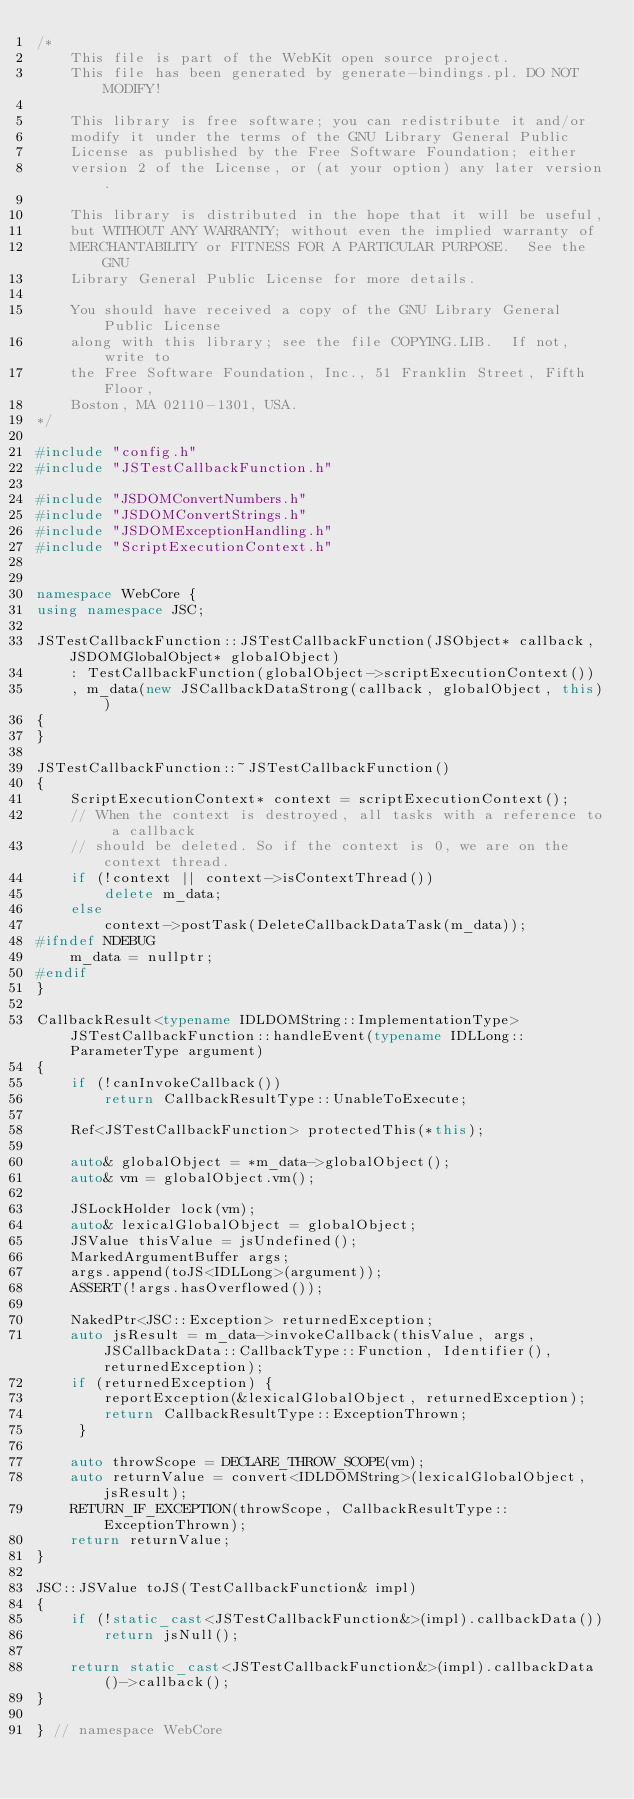Convert code to text. <code><loc_0><loc_0><loc_500><loc_500><_C++_>/*
    This file is part of the WebKit open source project.
    This file has been generated by generate-bindings.pl. DO NOT MODIFY!

    This library is free software; you can redistribute it and/or
    modify it under the terms of the GNU Library General Public
    License as published by the Free Software Foundation; either
    version 2 of the License, or (at your option) any later version.

    This library is distributed in the hope that it will be useful,
    but WITHOUT ANY WARRANTY; without even the implied warranty of
    MERCHANTABILITY or FITNESS FOR A PARTICULAR PURPOSE.  See the GNU
    Library General Public License for more details.

    You should have received a copy of the GNU Library General Public License
    along with this library; see the file COPYING.LIB.  If not, write to
    the Free Software Foundation, Inc., 51 Franklin Street, Fifth Floor,
    Boston, MA 02110-1301, USA.
*/

#include "config.h"
#include "JSTestCallbackFunction.h"

#include "JSDOMConvertNumbers.h"
#include "JSDOMConvertStrings.h"
#include "JSDOMExceptionHandling.h"
#include "ScriptExecutionContext.h"


namespace WebCore {
using namespace JSC;

JSTestCallbackFunction::JSTestCallbackFunction(JSObject* callback, JSDOMGlobalObject* globalObject)
    : TestCallbackFunction(globalObject->scriptExecutionContext())
    , m_data(new JSCallbackDataStrong(callback, globalObject, this))
{
}

JSTestCallbackFunction::~JSTestCallbackFunction()
{
    ScriptExecutionContext* context = scriptExecutionContext();
    // When the context is destroyed, all tasks with a reference to a callback
    // should be deleted. So if the context is 0, we are on the context thread.
    if (!context || context->isContextThread())
        delete m_data;
    else
        context->postTask(DeleteCallbackDataTask(m_data));
#ifndef NDEBUG
    m_data = nullptr;
#endif
}

CallbackResult<typename IDLDOMString::ImplementationType> JSTestCallbackFunction::handleEvent(typename IDLLong::ParameterType argument)
{
    if (!canInvokeCallback())
        return CallbackResultType::UnableToExecute;

    Ref<JSTestCallbackFunction> protectedThis(*this);

    auto& globalObject = *m_data->globalObject();
    auto& vm = globalObject.vm();

    JSLockHolder lock(vm);
    auto& lexicalGlobalObject = globalObject;
    JSValue thisValue = jsUndefined();
    MarkedArgumentBuffer args;
    args.append(toJS<IDLLong>(argument));
    ASSERT(!args.hasOverflowed());

    NakedPtr<JSC::Exception> returnedException;
    auto jsResult = m_data->invokeCallback(thisValue, args, JSCallbackData::CallbackType::Function, Identifier(), returnedException);
    if (returnedException) {
        reportException(&lexicalGlobalObject, returnedException);
        return CallbackResultType::ExceptionThrown;
     }

    auto throwScope = DECLARE_THROW_SCOPE(vm);
    auto returnValue = convert<IDLDOMString>(lexicalGlobalObject, jsResult);
    RETURN_IF_EXCEPTION(throwScope, CallbackResultType::ExceptionThrown);
    return returnValue;
}

JSC::JSValue toJS(TestCallbackFunction& impl)
{
    if (!static_cast<JSTestCallbackFunction&>(impl).callbackData())
        return jsNull();

    return static_cast<JSTestCallbackFunction&>(impl).callbackData()->callback();
}

} // namespace WebCore
</code> 